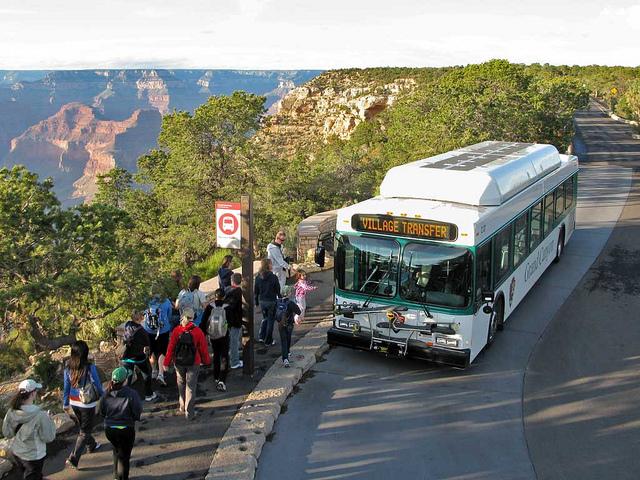Where is the bus going?
Answer briefly. Village. How many buses are there?
Give a very brief answer. 1. What are these people lined up to do?
Give a very brief answer. Get on bus. What make and model bus is that?
Keep it brief. Chevy. 